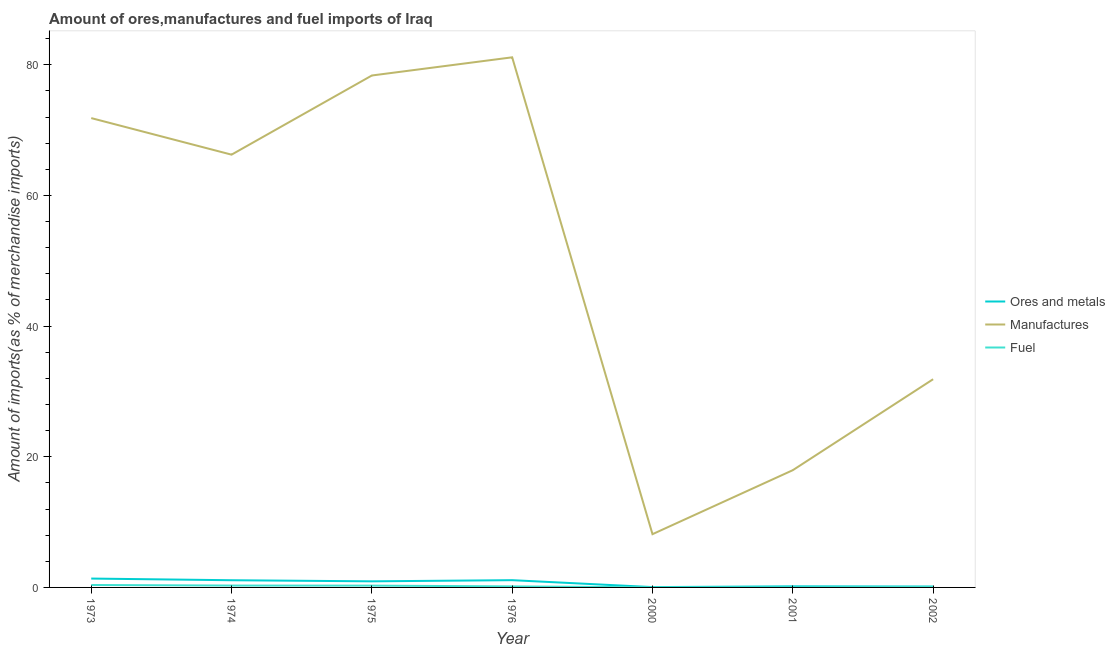How many different coloured lines are there?
Your answer should be very brief. 3. Is the number of lines equal to the number of legend labels?
Ensure brevity in your answer.  Yes. What is the percentage of fuel imports in 2000?
Offer a very short reply. 0.01. Across all years, what is the maximum percentage of ores and metals imports?
Your answer should be compact. 1.36. Across all years, what is the minimum percentage of fuel imports?
Provide a succinct answer. 0.01. In which year was the percentage of manufactures imports maximum?
Your response must be concise. 1976. What is the total percentage of manufactures imports in the graph?
Provide a short and direct response. 355.54. What is the difference between the percentage of manufactures imports in 1975 and that in 2002?
Provide a short and direct response. 46.49. What is the difference between the percentage of ores and metals imports in 1975 and the percentage of fuel imports in 2002?
Offer a very short reply. 0.85. What is the average percentage of ores and metals imports per year?
Offer a very short reply. 0.69. In the year 1973, what is the difference between the percentage of manufactures imports and percentage of ores and metals imports?
Offer a very short reply. 70.48. What is the ratio of the percentage of ores and metals imports in 1976 to that in 2001?
Provide a succinct answer. 6.64. Is the percentage of fuel imports in 1973 less than that in 1974?
Keep it short and to the point. No. What is the difference between the highest and the second highest percentage of ores and metals imports?
Your response must be concise. 0.25. What is the difference between the highest and the lowest percentage of fuel imports?
Offer a very short reply. 0.36. In how many years, is the percentage of fuel imports greater than the average percentage of fuel imports taken over all years?
Your response must be concise. 3. Is the sum of the percentage of ores and metals imports in 1974 and 1975 greater than the maximum percentage of fuel imports across all years?
Provide a short and direct response. Yes. Is the percentage of ores and metals imports strictly greater than the percentage of fuel imports over the years?
Your response must be concise. Yes. How many lines are there?
Provide a succinct answer. 3. How many years are there in the graph?
Offer a very short reply. 7. Are the values on the major ticks of Y-axis written in scientific E-notation?
Offer a very short reply. No. Does the graph contain any zero values?
Your answer should be very brief. No. Does the graph contain grids?
Offer a terse response. No. What is the title of the graph?
Ensure brevity in your answer.  Amount of ores,manufactures and fuel imports of Iraq. What is the label or title of the X-axis?
Give a very brief answer. Year. What is the label or title of the Y-axis?
Offer a very short reply. Amount of imports(as % of merchandise imports). What is the Amount of imports(as % of merchandise imports) in Ores and metals in 1973?
Your response must be concise. 1.36. What is the Amount of imports(as % of merchandise imports) of Manufactures in 1973?
Provide a succinct answer. 71.84. What is the Amount of imports(as % of merchandise imports) of Fuel in 1973?
Keep it short and to the point. 0.37. What is the Amount of imports(as % of merchandise imports) in Ores and metals in 1974?
Give a very brief answer. 1.1. What is the Amount of imports(as % of merchandise imports) of Manufactures in 1974?
Provide a short and direct response. 66.24. What is the Amount of imports(as % of merchandise imports) of Fuel in 1974?
Provide a short and direct response. 0.29. What is the Amount of imports(as % of merchandise imports) of Ores and metals in 1975?
Provide a short and direct response. 0.93. What is the Amount of imports(as % of merchandise imports) in Manufactures in 1975?
Give a very brief answer. 78.36. What is the Amount of imports(as % of merchandise imports) in Fuel in 1975?
Provide a short and direct response. 0.28. What is the Amount of imports(as % of merchandise imports) in Ores and metals in 1976?
Provide a succinct answer. 1.11. What is the Amount of imports(as % of merchandise imports) of Manufactures in 1976?
Your response must be concise. 81.14. What is the Amount of imports(as % of merchandise imports) of Fuel in 1976?
Provide a short and direct response. 0.16. What is the Amount of imports(as % of merchandise imports) of Ores and metals in 2000?
Make the answer very short. 0.05. What is the Amount of imports(as % of merchandise imports) in Manufactures in 2000?
Offer a terse response. 8.15. What is the Amount of imports(as % of merchandise imports) of Fuel in 2000?
Your response must be concise. 0.01. What is the Amount of imports(as % of merchandise imports) of Ores and metals in 2001?
Give a very brief answer. 0.17. What is the Amount of imports(as % of merchandise imports) in Manufactures in 2001?
Keep it short and to the point. 17.95. What is the Amount of imports(as % of merchandise imports) of Fuel in 2001?
Your answer should be compact. 0.02. What is the Amount of imports(as % of merchandise imports) of Ores and metals in 2002?
Give a very brief answer. 0.14. What is the Amount of imports(as % of merchandise imports) of Manufactures in 2002?
Your response must be concise. 31.87. What is the Amount of imports(as % of merchandise imports) in Fuel in 2002?
Offer a terse response. 0.08. Across all years, what is the maximum Amount of imports(as % of merchandise imports) in Ores and metals?
Your response must be concise. 1.36. Across all years, what is the maximum Amount of imports(as % of merchandise imports) of Manufactures?
Keep it short and to the point. 81.14. Across all years, what is the maximum Amount of imports(as % of merchandise imports) in Fuel?
Your answer should be very brief. 0.37. Across all years, what is the minimum Amount of imports(as % of merchandise imports) of Ores and metals?
Give a very brief answer. 0.05. Across all years, what is the minimum Amount of imports(as % of merchandise imports) of Manufactures?
Provide a short and direct response. 8.15. Across all years, what is the minimum Amount of imports(as % of merchandise imports) in Fuel?
Provide a succinct answer. 0.01. What is the total Amount of imports(as % of merchandise imports) in Ores and metals in the graph?
Keep it short and to the point. 4.86. What is the total Amount of imports(as % of merchandise imports) of Manufactures in the graph?
Offer a very short reply. 355.54. What is the total Amount of imports(as % of merchandise imports) in Fuel in the graph?
Make the answer very short. 1.21. What is the difference between the Amount of imports(as % of merchandise imports) of Ores and metals in 1973 and that in 1974?
Give a very brief answer. 0.26. What is the difference between the Amount of imports(as % of merchandise imports) in Manufactures in 1973 and that in 1974?
Ensure brevity in your answer.  5.6. What is the difference between the Amount of imports(as % of merchandise imports) in Fuel in 1973 and that in 1974?
Your answer should be very brief. 0.09. What is the difference between the Amount of imports(as % of merchandise imports) of Ores and metals in 1973 and that in 1975?
Your response must be concise. 0.42. What is the difference between the Amount of imports(as % of merchandise imports) of Manufactures in 1973 and that in 1975?
Your answer should be compact. -6.52. What is the difference between the Amount of imports(as % of merchandise imports) of Fuel in 1973 and that in 1975?
Give a very brief answer. 0.1. What is the difference between the Amount of imports(as % of merchandise imports) in Ores and metals in 1973 and that in 1976?
Offer a very short reply. 0.25. What is the difference between the Amount of imports(as % of merchandise imports) of Manufactures in 1973 and that in 1976?
Provide a short and direct response. -9.3. What is the difference between the Amount of imports(as % of merchandise imports) of Fuel in 1973 and that in 1976?
Your answer should be very brief. 0.22. What is the difference between the Amount of imports(as % of merchandise imports) in Ores and metals in 1973 and that in 2000?
Provide a succinct answer. 1.31. What is the difference between the Amount of imports(as % of merchandise imports) in Manufactures in 1973 and that in 2000?
Ensure brevity in your answer.  63.69. What is the difference between the Amount of imports(as % of merchandise imports) of Fuel in 1973 and that in 2000?
Your response must be concise. 0.36. What is the difference between the Amount of imports(as % of merchandise imports) in Ores and metals in 1973 and that in 2001?
Offer a very short reply. 1.19. What is the difference between the Amount of imports(as % of merchandise imports) in Manufactures in 1973 and that in 2001?
Your answer should be compact. 53.89. What is the difference between the Amount of imports(as % of merchandise imports) in Fuel in 1973 and that in 2001?
Your answer should be very brief. 0.36. What is the difference between the Amount of imports(as % of merchandise imports) in Ores and metals in 1973 and that in 2002?
Give a very brief answer. 1.22. What is the difference between the Amount of imports(as % of merchandise imports) in Manufactures in 1973 and that in 2002?
Provide a short and direct response. 39.97. What is the difference between the Amount of imports(as % of merchandise imports) in Fuel in 1973 and that in 2002?
Provide a short and direct response. 0.29. What is the difference between the Amount of imports(as % of merchandise imports) in Ores and metals in 1974 and that in 1975?
Your answer should be compact. 0.17. What is the difference between the Amount of imports(as % of merchandise imports) in Manufactures in 1974 and that in 1975?
Give a very brief answer. -12.12. What is the difference between the Amount of imports(as % of merchandise imports) of Fuel in 1974 and that in 1975?
Keep it short and to the point. 0.01. What is the difference between the Amount of imports(as % of merchandise imports) of Ores and metals in 1974 and that in 1976?
Keep it short and to the point. -0.01. What is the difference between the Amount of imports(as % of merchandise imports) of Manufactures in 1974 and that in 1976?
Your response must be concise. -14.9. What is the difference between the Amount of imports(as % of merchandise imports) of Fuel in 1974 and that in 1976?
Give a very brief answer. 0.13. What is the difference between the Amount of imports(as % of merchandise imports) of Ores and metals in 1974 and that in 2000?
Give a very brief answer. 1.05. What is the difference between the Amount of imports(as % of merchandise imports) in Manufactures in 1974 and that in 2000?
Offer a terse response. 58.09. What is the difference between the Amount of imports(as % of merchandise imports) of Fuel in 1974 and that in 2000?
Your answer should be compact. 0.27. What is the difference between the Amount of imports(as % of merchandise imports) of Ores and metals in 1974 and that in 2001?
Offer a terse response. 0.93. What is the difference between the Amount of imports(as % of merchandise imports) in Manufactures in 1974 and that in 2001?
Your answer should be very brief. 48.29. What is the difference between the Amount of imports(as % of merchandise imports) in Fuel in 1974 and that in 2001?
Offer a terse response. 0.27. What is the difference between the Amount of imports(as % of merchandise imports) in Ores and metals in 1974 and that in 2002?
Provide a short and direct response. 0.96. What is the difference between the Amount of imports(as % of merchandise imports) of Manufactures in 1974 and that in 2002?
Offer a very short reply. 34.37. What is the difference between the Amount of imports(as % of merchandise imports) of Fuel in 1974 and that in 2002?
Ensure brevity in your answer.  0.2. What is the difference between the Amount of imports(as % of merchandise imports) of Ores and metals in 1975 and that in 1976?
Your answer should be compact. -0.18. What is the difference between the Amount of imports(as % of merchandise imports) of Manufactures in 1975 and that in 1976?
Your answer should be compact. -2.78. What is the difference between the Amount of imports(as % of merchandise imports) in Fuel in 1975 and that in 1976?
Provide a short and direct response. 0.12. What is the difference between the Amount of imports(as % of merchandise imports) in Ores and metals in 1975 and that in 2000?
Ensure brevity in your answer.  0.88. What is the difference between the Amount of imports(as % of merchandise imports) in Manufactures in 1975 and that in 2000?
Offer a very short reply. 70.21. What is the difference between the Amount of imports(as % of merchandise imports) of Fuel in 1975 and that in 2000?
Keep it short and to the point. 0.26. What is the difference between the Amount of imports(as % of merchandise imports) of Ores and metals in 1975 and that in 2001?
Provide a succinct answer. 0.77. What is the difference between the Amount of imports(as % of merchandise imports) in Manufactures in 1975 and that in 2001?
Offer a very short reply. 60.41. What is the difference between the Amount of imports(as % of merchandise imports) in Fuel in 1975 and that in 2001?
Your response must be concise. 0.26. What is the difference between the Amount of imports(as % of merchandise imports) of Ores and metals in 1975 and that in 2002?
Ensure brevity in your answer.  0.8. What is the difference between the Amount of imports(as % of merchandise imports) of Manufactures in 1975 and that in 2002?
Keep it short and to the point. 46.49. What is the difference between the Amount of imports(as % of merchandise imports) in Fuel in 1975 and that in 2002?
Your response must be concise. 0.19. What is the difference between the Amount of imports(as % of merchandise imports) of Ores and metals in 1976 and that in 2000?
Ensure brevity in your answer.  1.06. What is the difference between the Amount of imports(as % of merchandise imports) of Manufactures in 1976 and that in 2000?
Keep it short and to the point. 72.99. What is the difference between the Amount of imports(as % of merchandise imports) of Fuel in 1976 and that in 2000?
Make the answer very short. 0.14. What is the difference between the Amount of imports(as % of merchandise imports) in Ores and metals in 1976 and that in 2001?
Make the answer very short. 0.94. What is the difference between the Amount of imports(as % of merchandise imports) in Manufactures in 1976 and that in 2001?
Make the answer very short. 63.19. What is the difference between the Amount of imports(as % of merchandise imports) of Fuel in 1976 and that in 2001?
Provide a succinct answer. 0.14. What is the difference between the Amount of imports(as % of merchandise imports) in Ores and metals in 1976 and that in 2002?
Keep it short and to the point. 0.97. What is the difference between the Amount of imports(as % of merchandise imports) in Manufactures in 1976 and that in 2002?
Give a very brief answer. 49.27. What is the difference between the Amount of imports(as % of merchandise imports) of Fuel in 1976 and that in 2002?
Offer a terse response. 0.08. What is the difference between the Amount of imports(as % of merchandise imports) in Ores and metals in 2000 and that in 2001?
Your response must be concise. -0.12. What is the difference between the Amount of imports(as % of merchandise imports) of Manufactures in 2000 and that in 2001?
Make the answer very short. -9.79. What is the difference between the Amount of imports(as % of merchandise imports) of Fuel in 2000 and that in 2001?
Offer a terse response. -0. What is the difference between the Amount of imports(as % of merchandise imports) in Ores and metals in 2000 and that in 2002?
Ensure brevity in your answer.  -0.09. What is the difference between the Amount of imports(as % of merchandise imports) in Manufactures in 2000 and that in 2002?
Give a very brief answer. -23.72. What is the difference between the Amount of imports(as % of merchandise imports) in Fuel in 2000 and that in 2002?
Provide a short and direct response. -0.07. What is the difference between the Amount of imports(as % of merchandise imports) of Ores and metals in 2001 and that in 2002?
Provide a short and direct response. 0.03. What is the difference between the Amount of imports(as % of merchandise imports) of Manufactures in 2001 and that in 2002?
Give a very brief answer. -13.92. What is the difference between the Amount of imports(as % of merchandise imports) of Fuel in 2001 and that in 2002?
Keep it short and to the point. -0.07. What is the difference between the Amount of imports(as % of merchandise imports) in Ores and metals in 1973 and the Amount of imports(as % of merchandise imports) in Manufactures in 1974?
Make the answer very short. -64.88. What is the difference between the Amount of imports(as % of merchandise imports) in Ores and metals in 1973 and the Amount of imports(as % of merchandise imports) in Fuel in 1974?
Your answer should be very brief. 1.07. What is the difference between the Amount of imports(as % of merchandise imports) in Manufactures in 1973 and the Amount of imports(as % of merchandise imports) in Fuel in 1974?
Make the answer very short. 71.55. What is the difference between the Amount of imports(as % of merchandise imports) in Ores and metals in 1973 and the Amount of imports(as % of merchandise imports) in Manufactures in 1975?
Offer a very short reply. -77. What is the difference between the Amount of imports(as % of merchandise imports) in Ores and metals in 1973 and the Amount of imports(as % of merchandise imports) in Fuel in 1975?
Provide a short and direct response. 1.08. What is the difference between the Amount of imports(as % of merchandise imports) of Manufactures in 1973 and the Amount of imports(as % of merchandise imports) of Fuel in 1975?
Your answer should be very brief. 71.56. What is the difference between the Amount of imports(as % of merchandise imports) in Ores and metals in 1973 and the Amount of imports(as % of merchandise imports) in Manufactures in 1976?
Provide a succinct answer. -79.78. What is the difference between the Amount of imports(as % of merchandise imports) in Ores and metals in 1973 and the Amount of imports(as % of merchandise imports) in Fuel in 1976?
Ensure brevity in your answer.  1.2. What is the difference between the Amount of imports(as % of merchandise imports) of Manufactures in 1973 and the Amount of imports(as % of merchandise imports) of Fuel in 1976?
Give a very brief answer. 71.68. What is the difference between the Amount of imports(as % of merchandise imports) of Ores and metals in 1973 and the Amount of imports(as % of merchandise imports) of Manufactures in 2000?
Give a very brief answer. -6.79. What is the difference between the Amount of imports(as % of merchandise imports) of Ores and metals in 1973 and the Amount of imports(as % of merchandise imports) of Fuel in 2000?
Provide a succinct answer. 1.34. What is the difference between the Amount of imports(as % of merchandise imports) of Manufactures in 1973 and the Amount of imports(as % of merchandise imports) of Fuel in 2000?
Make the answer very short. 71.82. What is the difference between the Amount of imports(as % of merchandise imports) of Ores and metals in 1973 and the Amount of imports(as % of merchandise imports) of Manufactures in 2001?
Give a very brief answer. -16.59. What is the difference between the Amount of imports(as % of merchandise imports) in Ores and metals in 1973 and the Amount of imports(as % of merchandise imports) in Fuel in 2001?
Your answer should be very brief. 1.34. What is the difference between the Amount of imports(as % of merchandise imports) in Manufactures in 1973 and the Amount of imports(as % of merchandise imports) in Fuel in 2001?
Ensure brevity in your answer.  71.82. What is the difference between the Amount of imports(as % of merchandise imports) in Ores and metals in 1973 and the Amount of imports(as % of merchandise imports) in Manufactures in 2002?
Make the answer very short. -30.51. What is the difference between the Amount of imports(as % of merchandise imports) in Ores and metals in 1973 and the Amount of imports(as % of merchandise imports) in Fuel in 2002?
Your response must be concise. 1.28. What is the difference between the Amount of imports(as % of merchandise imports) of Manufactures in 1973 and the Amount of imports(as % of merchandise imports) of Fuel in 2002?
Ensure brevity in your answer.  71.76. What is the difference between the Amount of imports(as % of merchandise imports) in Ores and metals in 1974 and the Amount of imports(as % of merchandise imports) in Manufactures in 1975?
Your answer should be compact. -77.26. What is the difference between the Amount of imports(as % of merchandise imports) of Ores and metals in 1974 and the Amount of imports(as % of merchandise imports) of Fuel in 1975?
Keep it short and to the point. 0.83. What is the difference between the Amount of imports(as % of merchandise imports) in Manufactures in 1974 and the Amount of imports(as % of merchandise imports) in Fuel in 1975?
Your answer should be very brief. 65.96. What is the difference between the Amount of imports(as % of merchandise imports) of Ores and metals in 1974 and the Amount of imports(as % of merchandise imports) of Manufactures in 1976?
Your response must be concise. -80.04. What is the difference between the Amount of imports(as % of merchandise imports) in Ores and metals in 1974 and the Amount of imports(as % of merchandise imports) in Fuel in 1976?
Provide a succinct answer. 0.94. What is the difference between the Amount of imports(as % of merchandise imports) of Manufactures in 1974 and the Amount of imports(as % of merchandise imports) of Fuel in 1976?
Make the answer very short. 66.08. What is the difference between the Amount of imports(as % of merchandise imports) of Ores and metals in 1974 and the Amount of imports(as % of merchandise imports) of Manufactures in 2000?
Give a very brief answer. -7.05. What is the difference between the Amount of imports(as % of merchandise imports) in Ores and metals in 1974 and the Amount of imports(as % of merchandise imports) in Fuel in 2000?
Keep it short and to the point. 1.09. What is the difference between the Amount of imports(as % of merchandise imports) in Manufactures in 1974 and the Amount of imports(as % of merchandise imports) in Fuel in 2000?
Give a very brief answer. 66.23. What is the difference between the Amount of imports(as % of merchandise imports) in Ores and metals in 1974 and the Amount of imports(as % of merchandise imports) in Manufactures in 2001?
Your answer should be very brief. -16.84. What is the difference between the Amount of imports(as % of merchandise imports) of Ores and metals in 1974 and the Amount of imports(as % of merchandise imports) of Fuel in 2001?
Offer a terse response. 1.09. What is the difference between the Amount of imports(as % of merchandise imports) in Manufactures in 1974 and the Amount of imports(as % of merchandise imports) in Fuel in 2001?
Ensure brevity in your answer.  66.22. What is the difference between the Amount of imports(as % of merchandise imports) in Ores and metals in 1974 and the Amount of imports(as % of merchandise imports) in Manufactures in 2002?
Offer a very short reply. -30.77. What is the difference between the Amount of imports(as % of merchandise imports) in Ores and metals in 1974 and the Amount of imports(as % of merchandise imports) in Fuel in 2002?
Offer a terse response. 1.02. What is the difference between the Amount of imports(as % of merchandise imports) in Manufactures in 1974 and the Amount of imports(as % of merchandise imports) in Fuel in 2002?
Make the answer very short. 66.16. What is the difference between the Amount of imports(as % of merchandise imports) of Ores and metals in 1975 and the Amount of imports(as % of merchandise imports) of Manufactures in 1976?
Your response must be concise. -80.2. What is the difference between the Amount of imports(as % of merchandise imports) in Ores and metals in 1975 and the Amount of imports(as % of merchandise imports) in Fuel in 1976?
Offer a terse response. 0.78. What is the difference between the Amount of imports(as % of merchandise imports) of Manufactures in 1975 and the Amount of imports(as % of merchandise imports) of Fuel in 1976?
Your response must be concise. 78.2. What is the difference between the Amount of imports(as % of merchandise imports) in Ores and metals in 1975 and the Amount of imports(as % of merchandise imports) in Manufactures in 2000?
Offer a very short reply. -7.22. What is the difference between the Amount of imports(as % of merchandise imports) of Ores and metals in 1975 and the Amount of imports(as % of merchandise imports) of Fuel in 2000?
Provide a succinct answer. 0.92. What is the difference between the Amount of imports(as % of merchandise imports) in Manufactures in 1975 and the Amount of imports(as % of merchandise imports) in Fuel in 2000?
Offer a terse response. 78.34. What is the difference between the Amount of imports(as % of merchandise imports) of Ores and metals in 1975 and the Amount of imports(as % of merchandise imports) of Manufactures in 2001?
Ensure brevity in your answer.  -17.01. What is the difference between the Amount of imports(as % of merchandise imports) of Ores and metals in 1975 and the Amount of imports(as % of merchandise imports) of Fuel in 2001?
Offer a terse response. 0.92. What is the difference between the Amount of imports(as % of merchandise imports) of Manufactures in 1975 and the Amount of imports(as % of merchandise imports) of Fuel in 2001?
Provide a short and direct response. 78.34. What is the difference between the Amount of imports(as % of merchandise imports) in Ores and metals in 1975 and the Amount of imports(as % of merchandise imports) in Manufactures in 2002?
Your answer should be very brief. -30.93. What is the difference between the Amount of imports(as % of merchandise imports) in Ores and metals in 1975 and the Amount of imports(as % of merchandise imports) in Fuel in 2002?
Offer a very short reply. 0.85. What is the difference between the Amount of imports(as % of merchandise imports) of Manufactures in 1975 and the Amount of imports(as % of merchandise imports) of Fuel in 2002?
Give a very brief answer. 78.28. What is the difference between the Amount of imports(as % of merchandise imports) in Ores and metals in 1976 and the Amount of imports(as % of merchandise imports) in Manufactures in 2000?
Offer a terse response. -7.04. What is the difference between the Amount of imports(as % of merchandise imports) in Ores and metals in 1976 and the Amount of imports(as % of merchandise imports) in Fuel in 2000?
Provide a short and direct response. 1.1. What is the difference between the Amount of imports(as % of merchandise imports) in Manufactures in 1976 and the Amount of imports(as % of merchandise imports) in Fuel in 2000?
Give a very brief answer. 81.12. What is the difference between the Amount of imports(as % of merchandise imports) in Ores and metals in 1976 and the Amount of imports(as % of merchandise imports) in Manufactures in 2001?
Your answer should be very brief. -16.83. What is the difference between the Amount of imports(as % of merchandise imports) in Ores and metals in 1976 and the Amount of imports(as % of merchandise imports) in Fuel in 2001?
Make the answer very short. 1.1. What is the difference between the Amount of imports(as % of merchandise imports) in Manufactures in 1976 and the Amount of imports(as % of merchandise imports) in Fuel in 2001?
Make the answer very short. 81.12. What is the difference between the Amount of imports(as % of merchandise imports) of Ores and metals in 1976 and the Amount of imports(as % of merchandise imports) of Manufactures in 2002?
Provide a succinct answer. -30.76. What is the difference between the Amount of imports(as % of merchandise imports) of Ores and metals in 1976 and the Amount of imports(as % of merchandise imports) of Fuel in 2002?
Provide a succinct answer. 1.03. What is the difference between the Amount of imports(as % of merchandise imports) of Manufactures in 1976 and the Amount of imports(as % of merchandise imports) of Fuel in 2002?
Keep it short and to the point. 81.06. What is the difference between the Amount of imports(as % of merchandise imports) of Ores and metals in 2000 and the Amount of imports(as % of merchandise imports) of Manufactures in 2001?
Give a very brief answer. -17.9. What is the difference between the Amount of imports(as % of merchandise imports) in Ores and metals in 2000 and the Amount of imports(as % of merchandise imports) in Fuel in 2001?
Your answer should be very brief. 0.03. What is the difference between the Amount of imports(as % of merchandise imports) in Manufactures in 2000 and the Amount of imports(as % of merchandise imports) in Fuel in 2001?
Give a very brief answer. 8.14. What is the difference between the Amount of imports(as % of merchandise imports) of Ores and metals in 2000 and the Amount of imports(as % of merchandise imports) of Manufactures in 2002?
Give a very brief answer. -31.82. What is the difference between the Amount of imports(as % of merchandise imports) in Ores and metals in 2000 and the Amount of imports(as % of merchandise imports) in Fuel in 2002?
Offer a very short reply. -0.03. What is the difference between the Amount of imports(as % of merchandise imports) of Manufactures in 2000 and the Amount of imports(as % of merchandise imports) of Fuel in 2002?
Offer a very short reply. 8.07. What is the difference between the Amount of imports(as % of merchandise imports) of Ores and metals in 2001 and the Amount of imports(as % of merchandise imports) of Manufactures in 2002?
Keep it short and to the point. -31.7. What is the difference between the Amount of imports(as % of merchandise imports) in Ores and metals in 2001 and the Amount of imports(as % of merchandise imports) in Fuel in 2002?
Offer a very short reply. 0.09. What is the difference between the Amount of imports(as % of merchandise imports) of Manufactures in 2001 and the Amount of imports(as % of merchandise imports) of Fuel in 2002?
Offer a very short reply. 17.86. What is the average Amount of imports(as % of merchandise imports) of Ores and metals per year?
Keep it short and to the point. 0.69. What is the average Amount of imports(as % of merchandise imports) of Manufactures per year?
Ensure brevity in your answer.  50.79. What is the average Amount of imports(as % of merchandise imports) of Fuel per year?
Ensure brevity in your answer.  0.17. In the year 1973, what is the difference between the Amount of imports(as % of merchandise imports) of Ores and metals and Amount of imports(as % of merchandise imports) of Manufactures?
Your response must be concise. -70.48. In the year 1973, what is the difference between the Amount of imports(as % of merchandise imports) in Ores and metals and Amount of imports(as % of merchandise imports) in Fuel?
Provide a short and direct response. 0.98. In the year 1973, what is the difference between the Amount of imports(as % of merchandise imports) of Manufactures and Amount of imports(as % of merchandise imports) of Fuel?
Ensure brevity in your answer.  71.46. In the year 1974, what is the difference between the Amount of imports(as % of merchandise imports) of Ores and metals and Amount of imports(as % of merchandise imports) of Manufactures?
Keep it short and to the point. -65.14. In the year 1974, what is the difference between the Amount of imports(as % of merchandise imports) in Ores and metals and Amount of imports(as % of merchandise imports) in Fuel?
Ensure brevity in your answer.  0.82. In the year 1974, what is the difference between the Amount of imports(as % of merchandise imports) in Manufactures and Amount of imports(as % of merchandise imports) in Fuel?
Your answer should be compact. 65.95. In the year 1975, what is the difference between the Amount of imports(as % of merchandise imports) of Ores and metals and Amount of imports(as % of merchandise imports) of Manufactures?
Offer a very short reply. -77.42. In the year 1975, what is the difference between the Amount of imports(as % of merchandise imports) in Ores and metals and Amount of imports(as % of merchandise imports) in Fuel?
Ensure brevity in your answer.  0.66. In the year 1975, what is the difference between the Amount of imports(as % of merchandise imports) of Manufactures and Amount of imports(as % of merchandise imports) of Fuel?
Provide a short and direct response. 78.08. In the year 1976, what is the difference between the Amount of imports(as % of merchandise imports) in Ores and metals and Amount of imports(as % of merchandise imports) in Manufactures?
Offer a terse response. -80.03. In the year 1976, what is the difference between the Amount of imports(as % of merchandise imports) of Ores and metals and Amount of imports(as % of merchandise imports) of Fuel?
Offer a terse response. 0.95. In the year 1976, what is the difference between the Amount of imports(as % of merchandise imports) of Manufactures and Amount of imports(as % of merchandise imports) of Fuel?
Make the answer very short. 80.98. In the year 2000, what is the difference between the Amount of imports(as % of merchandise imports) in Ores and metals and Amount of imports(as % of merchandise imports) in Manufactures?
Keep it short and to the point. -8.1. In the year 2000, what is the difference between the Amount of imports(as % of merchandise imports) of Ores and metals and Amount of imports(as % of merchandise imports) of Fuel?
Offer a terse response. 0.04. In the year 2000, what is the difference between the Amount of imports(as % of merchandise imports) in Manufactures and Amount of imports(as % of merchandise imports) in Fuel?
Offer a terse response. 8.14. In the year 2001, what is the difference between the Amount of imports(as % of merchandise imports) in Ores and metals and Amount of imports(as % of merchandise imports) in Manufactures?
Your answer should be very brief. -17.78. In the year 2001, what is the difference between the Amount of imports(as % of merchandise imports) of Ores and metals and Amount of imports(as % of merchandise imports) of Fuel?
Provide a short and direct response. 0.15. In the year 2001, what is the difference between the Amount of imports(as % of merchandise imports) of Manufactures and Amount of imports(as % of merchandise imports) of Fuel?
Offer a terse response. 17.93. In the year 2002, what is the difference between the Amount of imports(as % of merchandise imports) in Ores and metals and Amount of imports(as % of merchandise imports) in Manufactures?
Give a very brief answer. -31.73. In the year 2002, what is the difference between the Amount of imports(as % of merchandise imports) in Ores and metals and Amount of imports(as % of merchandise imports) in Fuel?
Keep it short and to the point. 0.06. In the year 2002, what is the difference between the Amount of imports(as % of merchandise imports) of Manufactures and Amount of imports(as % of merchandise imports) of Fuel?
Ensure brevity in your answer.  31.79. What is the ratio of the Amount of imports(as % of merchandise imports) in Ores and metals in 1973 to that in 1974?
Your answer should be very brief. 1.23. What is the ratio of the Amount of imports(as % of merchandise imports) of Manufactures in 1973 to that in 1974?
Make the answer very short. 1.08. What is the ratio of the Amount of imports(as % of merchandise imports) in Fuel in 1973 to that in 1974?
Offer a very short reply. 1.31. What is the ratio of the Amount of imports(as % of merchandise imports) of Ores and metals in 1973 to that in 1975?
Make the answer very short. 1.45. What is the ratio of the Amount of imports(as % of merchandise imports) in Manufactures in 1973 to that in 1975?
Your response must be concise. 0.92. What is the ratio of the Amount of imports(as % of merchandise imports) of Fuel in 1973 to that in 1975?
Give a very brief answer. 1.35. What is the ratio of the Amount of imports(as % of merchandise imports) in Ores and metals in 1973 to that in 1976?
Keep it short and to the point. 1.22. What is the ratio of the Amount of imports(as % of merchandise imports) of Manufactures in 1973 to that in 1976?
Offer a terse response. 0.89. What is the ratio of the Amount of imports(as % of merchandise imports) of Fuel in 1973 to that in 1976?
Give a very brief answer. 2.37. What is the ratio of the Amount of imports(as % of merchandise imports) in Ores and metals in 1973 to that in 2000?
Ensure brevity in your answer.  27.13. What is the ratio of the Amount of imports(as % of merchandise imports) in Manufactures in 1973 to that in 2000?
Offer a terse response. 8.81. What is the ratio of the Amount of imports(as % of merchandise imports) of Fuel in 1973 to that in 2000?
Provide a succinct answer. 25.09. What is the ratio of the Amount of imports(as % of merchandise imports) of Ores and metals in 1973 to that in 2001?
Your answer should be very brief. 8.11. What is the ratio of the Amount of imports(as % of merchandise imports) in Manufactures in 1973 to that in 2001?
Your response must be concise. 4. What is the ratio of the Amount of imports(as % of merchandise imports) in Fuel in 1973 to that in 2001?
Provide a short and direct response. 24.07. What is the ratio of the Amount of imports(as % of merchandise imports) in Ores and metals in 1973 to that in 2002?
Ensure brevity in your answer.  9.86. What is the ratio of the Amount of imports(as % of merchandise imports) in Manufactures in 1973 to that in 2002?
Make the answer very short. 2.25. What is the ratio of the Amount of imports(as % of merchandise imports) in Fuel in 1973 to that in 2002?
Offer a terse response. 4.59. What is the ratio of the Amount of imports(as % of merchandise imports) of Ores and metals in 1974 to that in 1975?
Offer a terse response. 1.18. What is the ratio of the Amount of imports(as % of merchandise imports) of Manufactures in 1974 to that in 1975?
Provide a short and direct response. 0.85. What is the ratio of the Amount of imports(as % of merchandise imports) of Fuel in 1974 to that in 1975?
Give a very brief answer. 1.03. What is the ratio of the Amount of imports(as % of merchandise imports) in Manufactures in 1974 to that in 1976?
Your response must be concise. 0.82. What is the ratio of the Amount of imports(as % of merchandise imports) of Fuel in 1974 to that in 1976?
Your response must be concise. 1.81. What is the ratio of the Amount of imports(as % of merchandise imports) of Ores and metals in 1974 to that in 2000?
Provide a succinct answer. 22.01. What is the ratio of the Amount of imports(as % of merchandise imports) of Manufactures in 1974 to that in 2000?
Give a very brief answer. 8.13. What is the ratio of the Amount of imports(as % of merchandise imports) in Fuel in 1974 to that in 2000?
Offer a terse response. 19.17. What is the ratio of the Amount of imports(as % of merchandise imports) of Ores and metals in 1974 to that in 2001?
Give a very brief answer. 6.58. What is the ratio of the Amount of imports(as % of merchandise imports) in Manufactures in 1974 to that in 2001?
Your answer should be compact. 3.69. What is the ratio of the Amount of imports(as % of merchandise imports) of Fuel in 1974 to that in 2001?
Offer a terse response. 18.39. What is the ratio of the Amount of imports(as % of merchandise imports) in Ores and metals in 1974 to that in 2002?
Your answer should be very brief. 8. What is the ratio of the Amount of imports(as % of merchandise imports) of Manufactures in 1974 to that in 2002?
Ensure brevity in your answer.  2.08. What is the ratio of the Amount of imports(as % of merchandise imports) in Fuel in 1974 to that in 2002?
Give a very brief answer. 3.51. What is the ratio of the Amount of imports(as % of merchandise imports) in Ores and metals in 1975 to that in 1976?
Ensure brevity in your answer.  0.84. What is the ratio of the Amount of imports(as % of merchandise imports) in Manufactures in 1975 to that in 1976?
Your answer should be very brief. 0.97. What is the ratio of the Amount of imports(as % of merchandise imports) in Fuel in 1975 to that in 1976?
Offer a very short reply. 1.75. What is the ratio of the Amount of imports(as % of merchandise imports) in Ores and metals in 1975 to that in 2000?
Provide a short and direct response. 18.67. What is the ratio of the Amount of imports(as % of merchandise imports) in Manufactures in 1975 to that in 2000?
Give a very brief answer. 9.61. What is the ratio of the Amount of imports(as % of merchandise imports) of Fuel in 1975 to that in 2000?
Your answer should be very brief. 18.53. What is the ratio of the Amount of imports(as % of merchandise imports) of Ores and metals in 1975 to that in 2001?
Make the answer very short. 5.58. What is the ratio of the Amount of imports(as % of merchandise imports) in Manufactures in 1975 to that in 2001?
Make the answer very short. 4.37. What is the ratio of the Amount of imports(as % of merchandise imports) in Fuel in 1975 to that in 2001?
Give a very brief answer. 17.78. What is the ratio of the Amount of imports(as % of merchandise imports) in Ores and metals in 1975 to that in 2002?
Provide a succinct answer. 6.78. What is the ratio of the Amount of imports(as % of merchandise imports) in Manufactures in 1975 to that in 2002?
Offer a terse response. 2.46. What is the ratio of the Amount of imports(as % of merchandise imports) of Fuel in 1975 to that in 2002?
Your answer should be very brief. 3.39. What is the ratio of the Amount of imports(as % of merchandise imports) in Ores and metals in 1976 to that in 2000?
Provide a succinct answer. 22.2. What is the ratio of the Amount of imports(as % of merchandise imports) of Manufactures in 1976 to that in 2000?
Provide a short and direct response. 9.95. What is the ratio of the Amount of imports(as % of merchandise imports) in Fuel in 1976 to that in 2000?
Your answer should be compact. 10.59. What is the ratio of the Amount of imports(as % of merchandise imports) in Ores and metals in 1976 to that in 2001?
Your answer should be compact. 6.64. What is the ratio of the Amount of imports(as % of merchandise imports) of Manufactures in 1976 to that in 2001?
Offer a very short reply. 4.52. What is the ratio of the Amount of imports(as % of merchandise imports) of Fuel in 1976 to that in 2001?
Provide a short and direct response. 10.16. What is the ratio of the Amount of imports(as % of merchandise imports) in Ores and metals in 1976 to that in 2002?
Ensure brevity in your answer.  8.07. What is the ratio of the Amount of imports(as % of merchandise imports) in Manufactures in 1976 to that in 2002?
Provide a succinct answer. 2.55. What is the ratio of the Amount of imports(as % of merchandise imports) in Fuel in 1976 to that in 2002?
Your response must be concise. 1.94. What is the ratio of the Amount of imports(as % of merchandise imports) of Ores and metals in 2000 to that in 2001?
Provide a short and direct response. 0.3. What is the ratio of the Amount of imports(as % of merchandise imports) in Manufactures in 2000 to that in 2001?
Offer a terse response. 0.45. What is the ratio of the Amount of imports(as % of merchandise imports) in Fuel in 2000 to that in 2001?
Keep it short and to the point. 0.96. What is the ratio of the Amount of imports(as % of merchandise imports) in Ores and metals in 2000 to that in 2002?
Make the answer very short. 0.36. What is the ratio of the Amount of imports(as % of merchandise imports) of Manufactures in 2000 to that in 2002?
Offer a terse response. 0.26. What is the ratio of the Amount of imports(as % of merchandise imports) of Fuel in 2000 to that in 2002?
Give a very brief answer. 0.18. What is the ratio of the Amount of imports(as % of merchandise imports) of Ores and metals in 2001 to that in 2002?
Offer a terse response. 1.22. What is the ratio of the Amount of imports(as % of merchandise imports) of Manufactures in 2001 to that in 2002?
Your answer should be compact. 0.56. What is the ratio of the Amount of imports(as % of merchandise imports) in Fuel in 2001 to that in 2002?
Keep it short and to the point. 0.19. What is the difference between the highest and the second highest Amount of imports(as % of merchandise imports) in Ores and metals?
Keep it short and to the point. 0.25. What is the difference between the highest and the second highest Amount of imports(as % of merchandise imports) of Manufactures?
Your response must be concise. 2.78. What is the difference between the highest and the second highest Amount of imports(as % of merchandise imports) in Fuel?
Offer a very short reply. 0.09. What is the difference between the highest and the lowest Amount of imports(as % of merchandise imports) in Ores and metals?
Provide a succinct answer. 1.31. What is the difference between the highest and the lowest Amount of imports(as % of merchandise imports) in Manufactures?
Keep it short and to the point. 72.99. What is the difference between the highest and the lowest Amount of imports(as % of merchandise imports) in Fuel?
Make the answer very short. 0.36. 